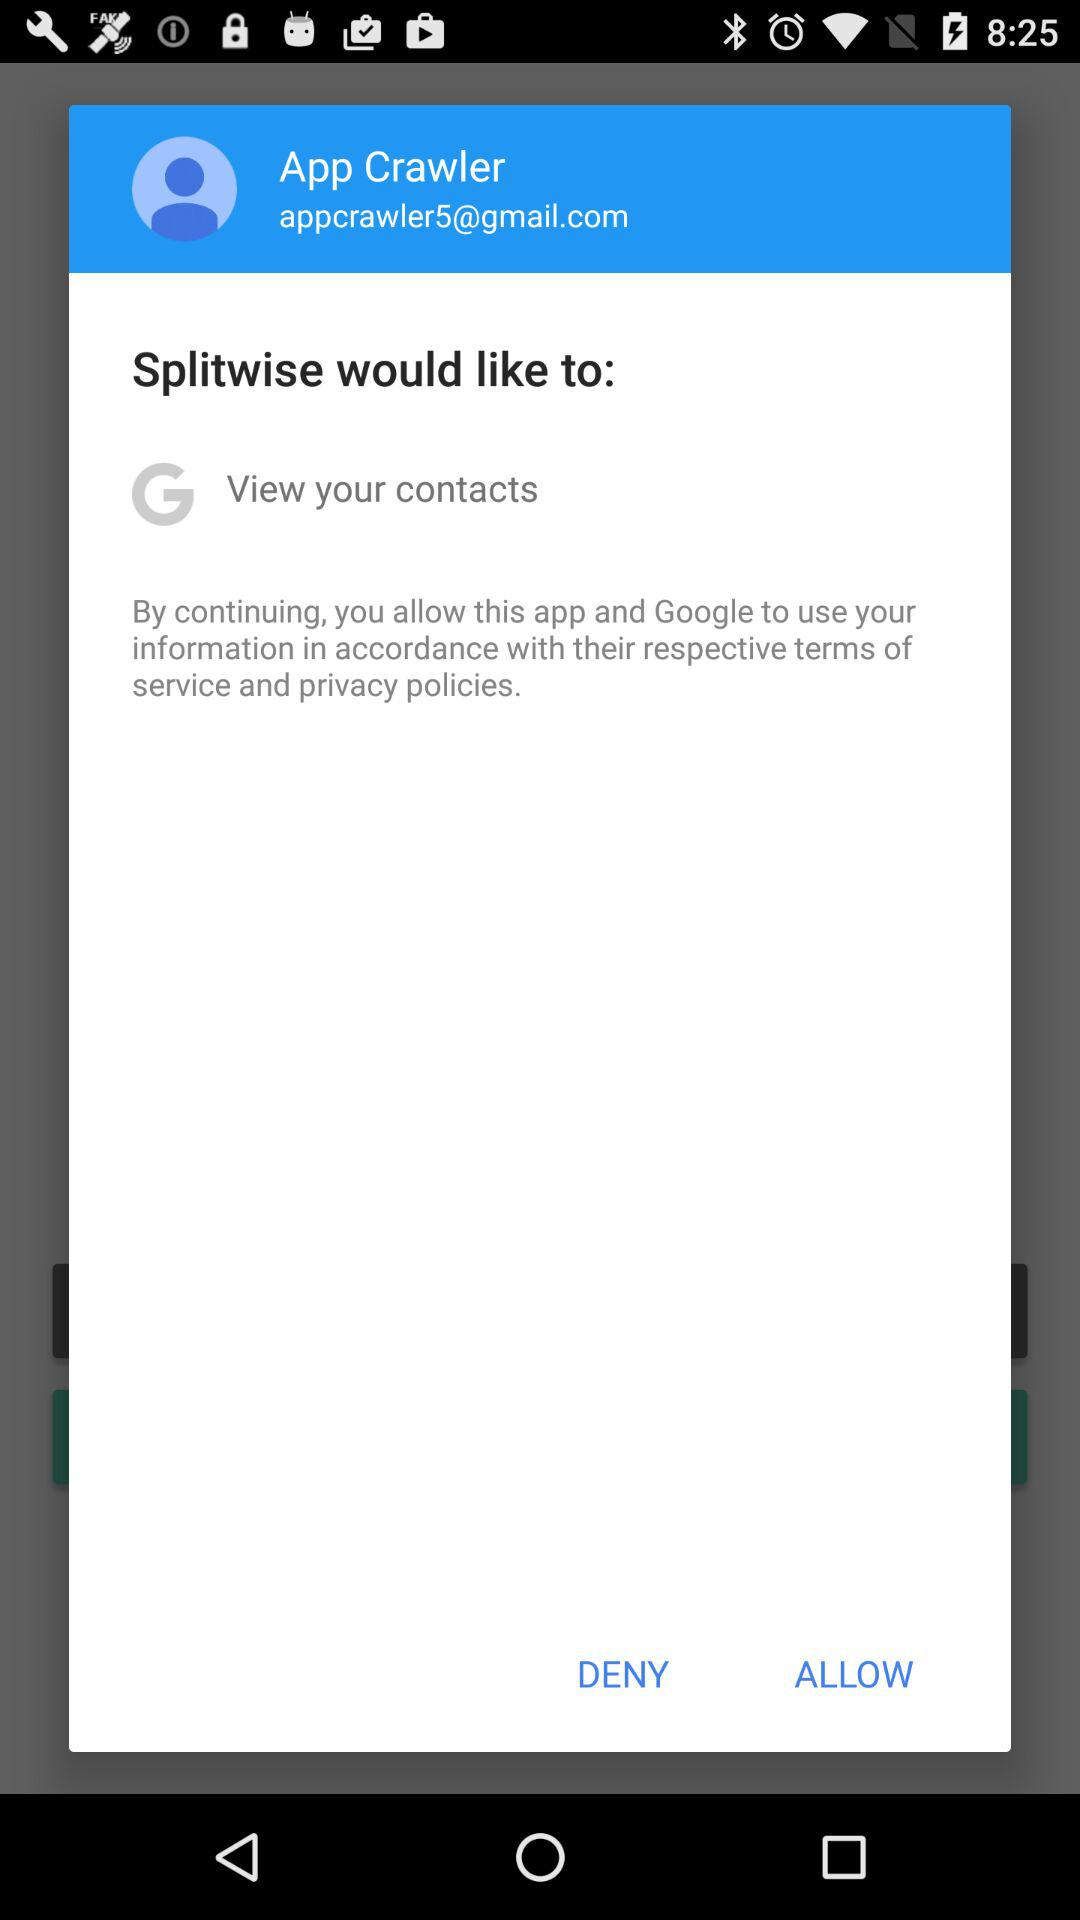Which application is asking for permission? The applications asking for permission are "Splitwise" and "Google". 